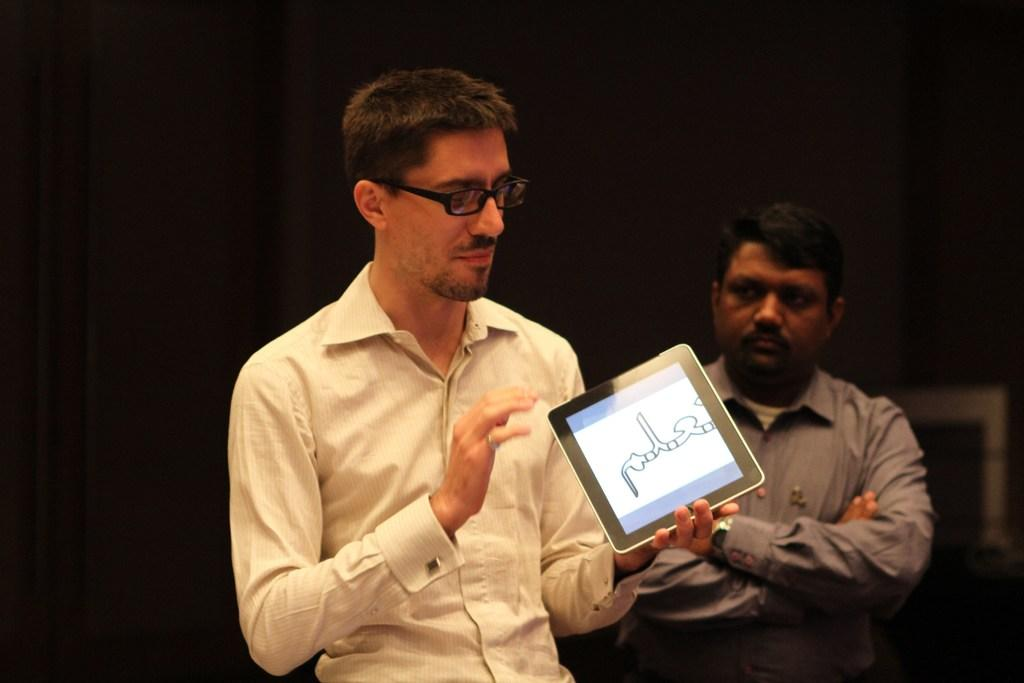What is the person in the image holding? The person is holding a device in the image. What is the person doing with the device? The person is looking at the device. Can you describe the person's appearance? The person is wearing spectacles. What can be seen in the background of the image? There is another person in the background of the image. How would you describe the lighting in the image? The background of the image is dark. What type of bed is visible in the image? There is no bed present in the image. How does the person in the image plan to attack the low-flying aircraft? There is no mention of an aircraft or an attack in the image. 